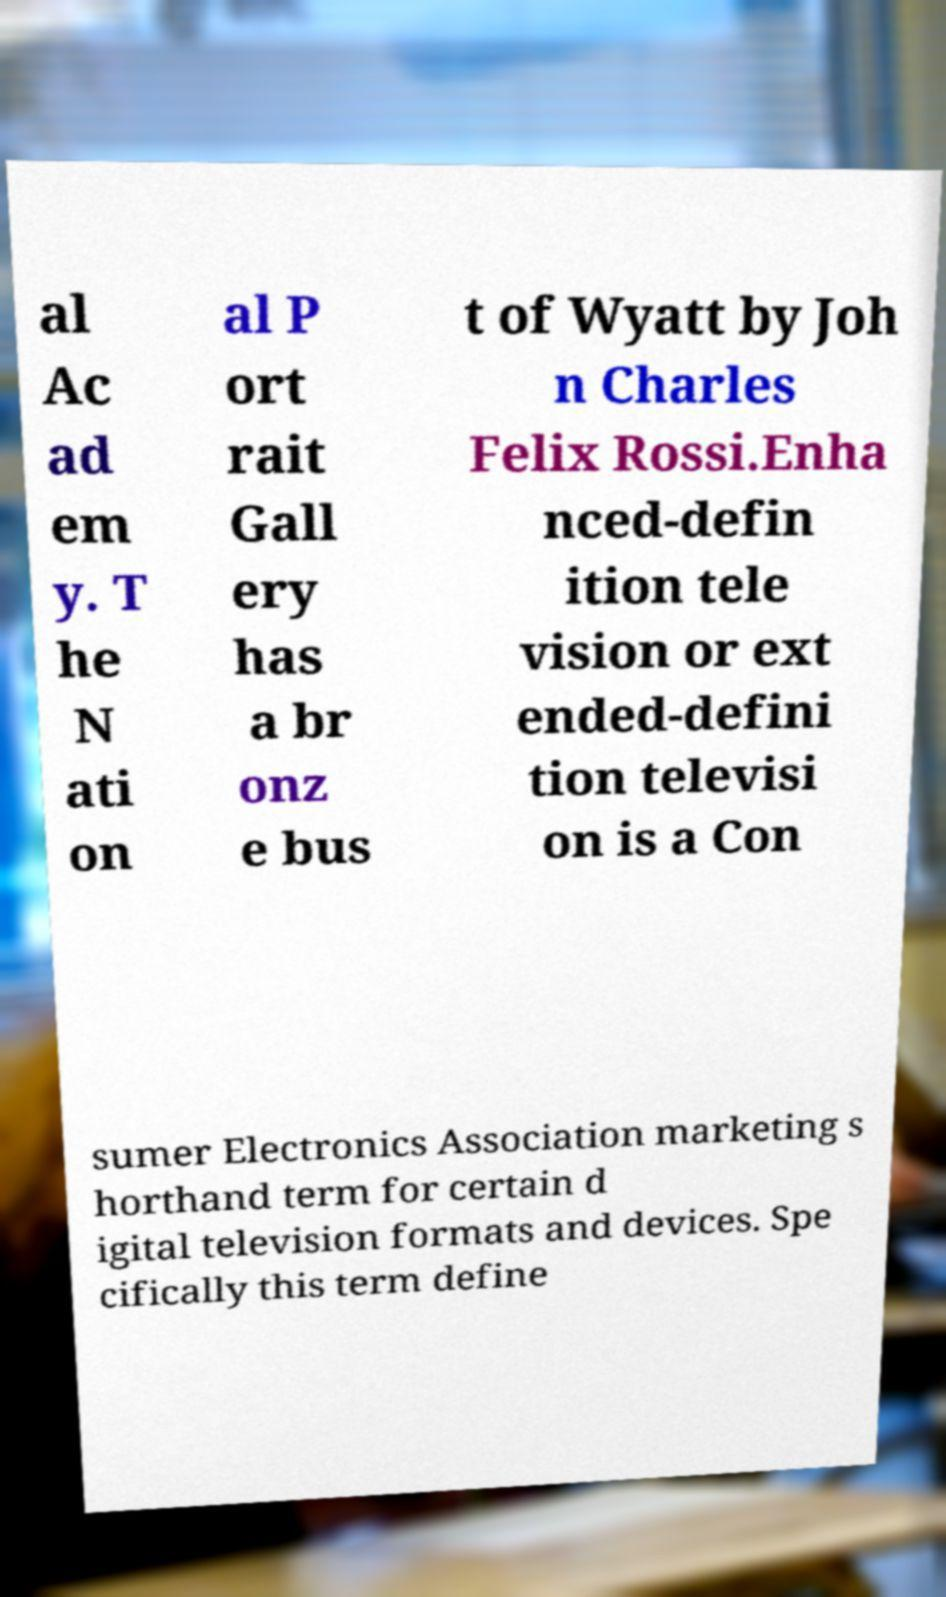Could you assist in decoding the text presented in this image and type it out clearly? al Ac ad em y. T he N ati on al P ort rait Gall ery has a br onz e bus t of Wyatt by Joh n Charles Felix Rossi.Enha nced-defin ition tele vision or ext ended-defini tion televisi on is a Con sumer Electronics Association marketing s horthand term for certain d igital television formats and devices. Spe cifically this term define 